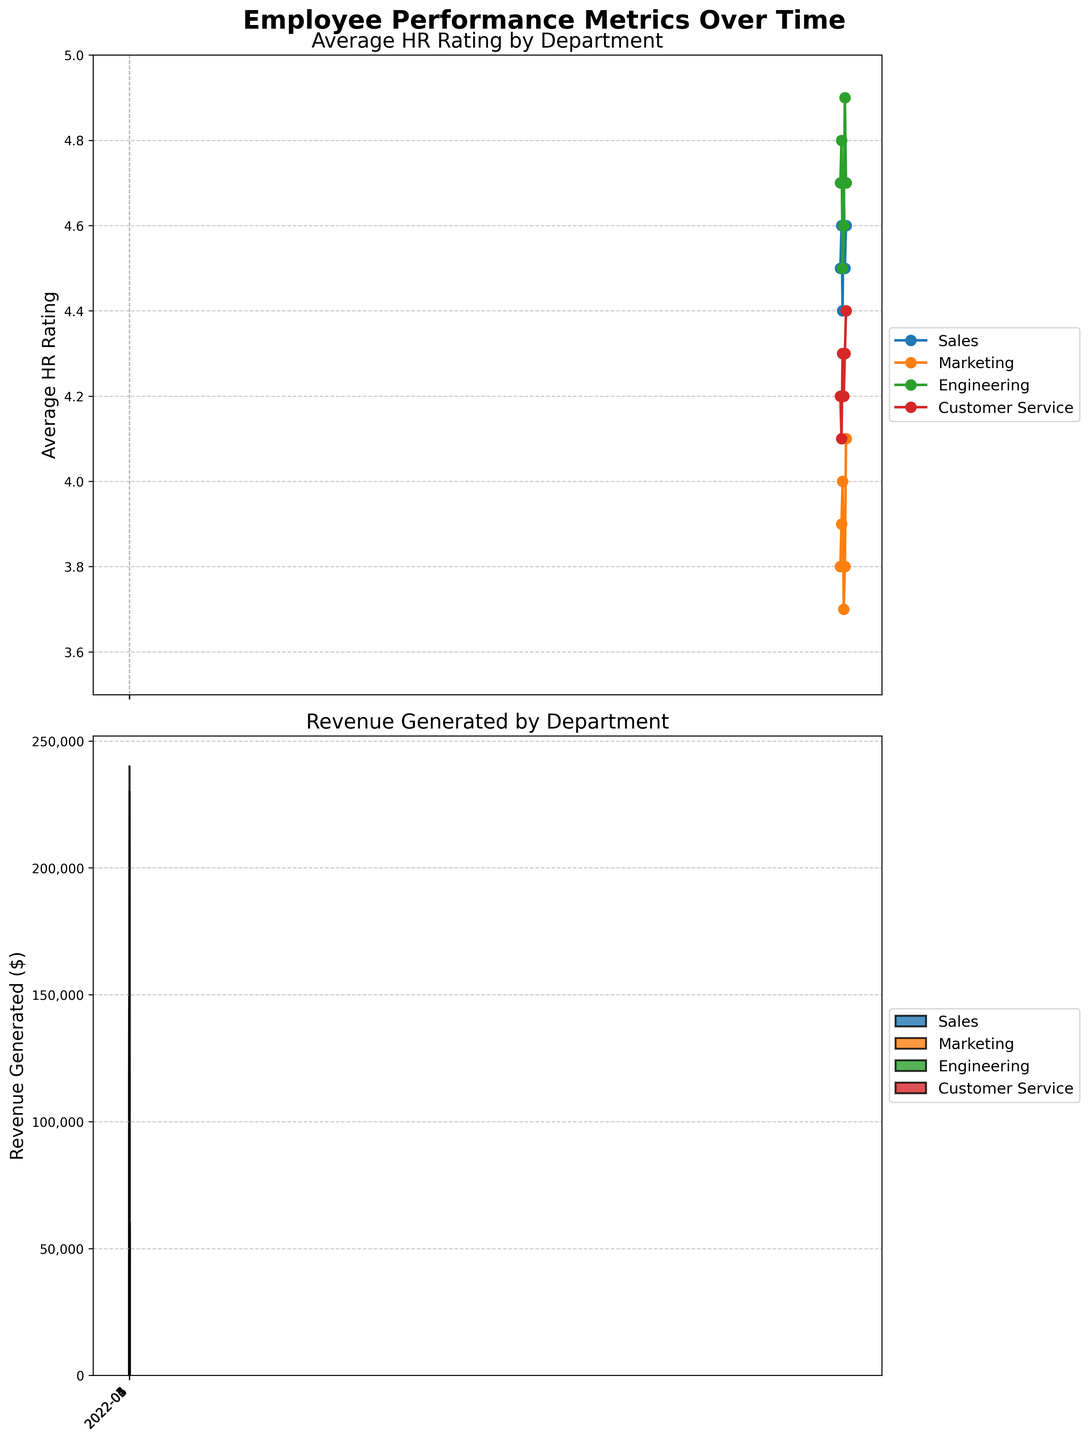What are the two performance metrics shown in the figure? The figure has two plots and titles. The first plot provides the 'Average HR Rating by Department,' and the second plot provides 'Revenue Generated by Department.' Both titles clearly indicate the metrics.
Answer: Average HR Rating, Revenue Generated Which department has the highest average HR rating in June 2022? The top plot shows several colored lines corresponding to different departments. For June 2022, the 'Engineering' line is the highest on the Y-axis, indicating it's the top.
Answer: Engineering How much revenue did the Marketing department generate in April 2022? In the bottom plot, look for the bar labeled 'Marketing' for April 2022. The height of this bar, combined with the Y-axis labels and format, provides the revenue.
Answer: 42,000 What trend is seen in the client satisfaction score of the Sales department over time? Though 'Client Satisfaction' is not a main metric shown in title or axes, we can infer its trend from the table provided. For Sales, the satisfaction score fluctuates slightly but generally stays in the mid to high 80s.
Answer: Fluctuating but stable in the mid to high 80s Which department showed the most improvement in revenue generation from February 2022 to March 2022? In the bottom plot, check the revenue bars for each department between February and March. Largest increase is seen for 'Sales,' which jumps from around 135,000 to 125,000. Engineering also increases but less significantly.
Answer: Sales Across all departments, which metric shows more variability, Average HR Rating or Revenue Generated? Comparing the two plots, HR Ratings range between approximately 3.7 and 4.9 (relatively small range) in the top plot. Revenue ranges from around 40,000 to 240,000 in the bottom plot. The revenue values clearly show more variability.
Answer: Revenue Generated How does the average HR rating of the Customer Service department in May 2022 compare to June 2022? On the top plot, find the line for 'Customer Service' and compare its position in May 2022 to June 2022. The HR rating shows a slight increase from 4.3 in May to 4.4 in June.
Answer: Increased from 4.3 to 4.4 Which month had the highest overall revenue generation? By observing the overall height of the bars for all departments in the bottom plot, May 2022 appears to have higher total revenue compared to other months, especially bolstered by high revenues in the Engineering and Sales departments.
Answer: May 2022 Comparing Sales and Engineering, which department performs consistently better in terms of revenue generation? Observing the bottom plot throughout all months, Engineering always has higher revenue bars compared to Sales, indicating consistent outperformance in revenue generation.
Answer: Engineering 